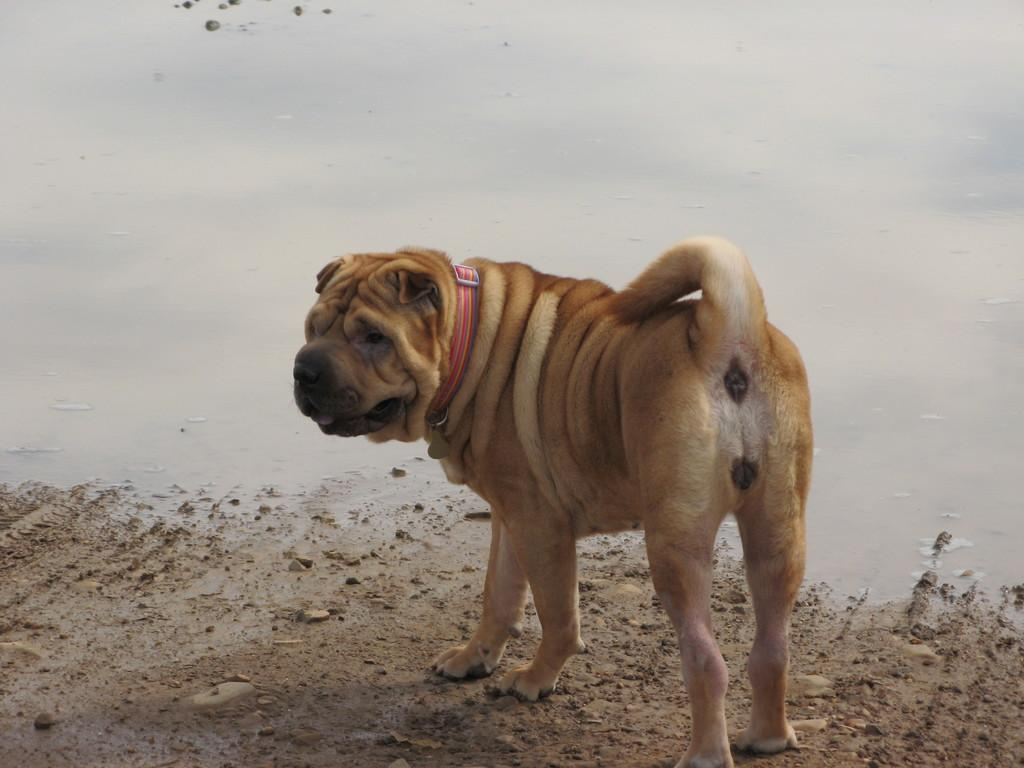What animal is present in the image? There is a dog in the image. What is the dog wearing? The dog is wearing a belt. Where is the dog standing? The dog is standing on the ground. What can be seen in the background of the image? There is water visible in the image. What type of hook can be seen hanging from the dog's collar in the image? There is no hook visible on the dog's collar in the image. 